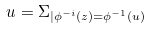<formula> <loc_0><loc_0><loc_500><loc_500>u = \Sigma _ { | \phi ^ { - i } ( z ) = \phi ^ { - 1 } ( u ) }</formula> 